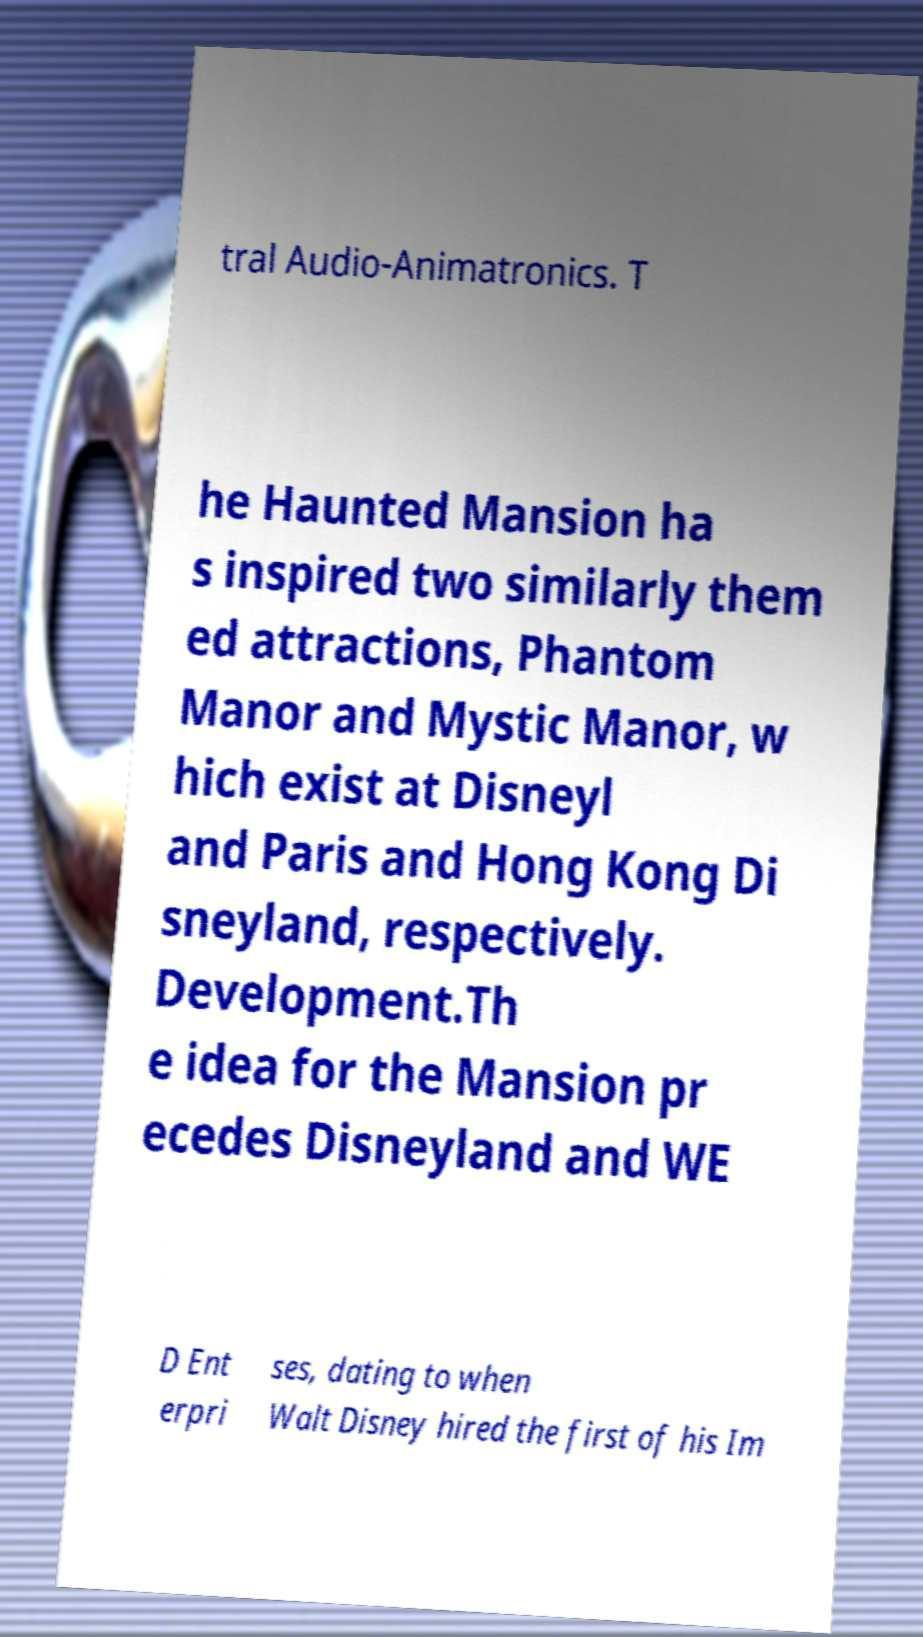Can you read and provide the text displayed in the image?This photo seems to have some interesting text. Can you extract and type it out for me? tral Audio-Animatronics. T he Haunted Mansion ha s inspired two similarly them ed attractions, Phantom Manor and Mystic Manor, w hich exist at Disneyl and Paris and Hong Kong Di sneyland, respectively. Development.Th e idea for the Mansion pr ecedes Disneyland and WE D Ent erpri ses, dating to when Walt Disney hired the first of his Im 